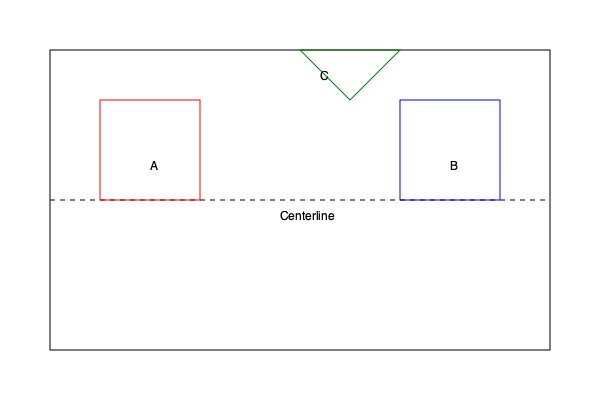Based on the floor plan diagram, which area is most likely to indicate a potential structural issue that a home inspector should carefully examine? To identify potential structural issues in this floor plan diagram, we need to analyze each marked area:

1. Area A (red square on the left):
   - Regular shape, symmetrically placed
   - No obvious signs of structural concern

2. Area B (blue square on the right):
   - Regular shape, symmetrically placed
   - No obvious signs of structural concern

3. Area C (green triangle at the top center):
   - Irregular shape
   - Located at the roof line
   - Asymmetrical placement

Structural issues are often associated with:
- Irregularities in the building's shape
- Asymmetrical designs
- Areas where different structural elements meet

Area C exhibits these characteristics:
- It's an irregular shape (triangle)
- It's located at the roofline, where load-bearing elements often meet
- It's asymmetrically placed relative to the building's centerline

These factors make Area C the most likely location for potential structural issues, such as:
- Improper load distribution
- Possible water intrusion points
- Challenging roof support structure

A home inspector should pay special attention to this area, checking for:
- Proper support beams
- Adequate waterproofing
- Signs of stress or movement in the surrounding structure
Answer: Area C (green triangle) 